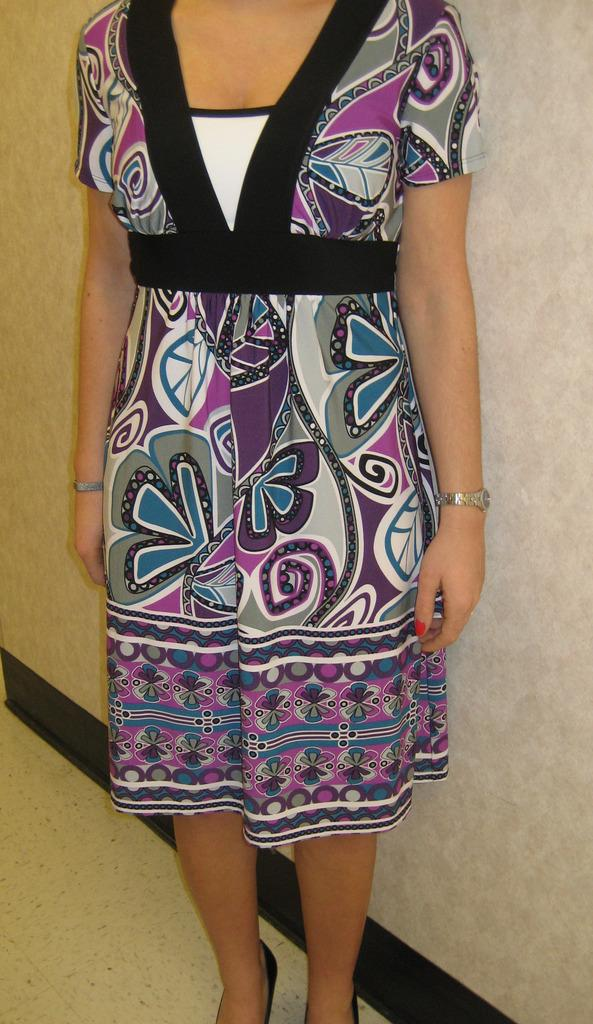Who is present in the image? There is a woman in the image. What is the woman doing in the image? The woman is standing. What accessory is the woman wearing on her wrist? The woman is wearing a wrist watch. What can be seen in the background of the image? There is a cream-colored wall in the background of the image. What type of knife is the woman using to cut the sack in the image? There is no knife or sack present in the image; it only features a woman standing and wearing a wrist watch. 